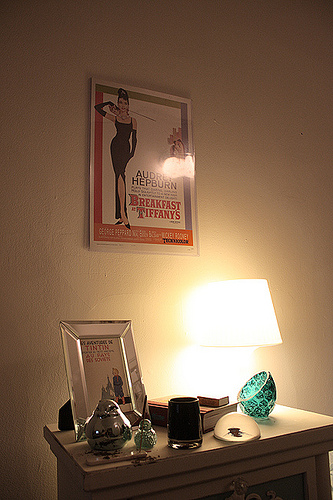<image>
Can you confirm if the wall is next to the frame? No. The wall is not positioned next to the frame. They are located in different areas of the scene. Is there a picture above the table? No. The picture is not positioned above the table. The vertical arrangement shows a different relationship. 